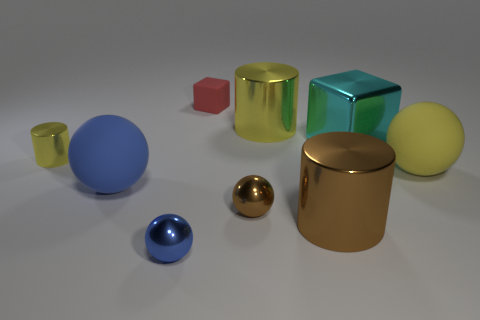Subtract all balls. How many objects are left? 5 Add 6 small brown balls. How many small brown balls exist? 7 Subtract 0 cyan balls. How many objects are left? 9 Subtract all small yellow cylinders. Subtract all small blue spheres. How many objects are left? 7 Add 9 brown cylinders. How many brown cylinders are left? 10 